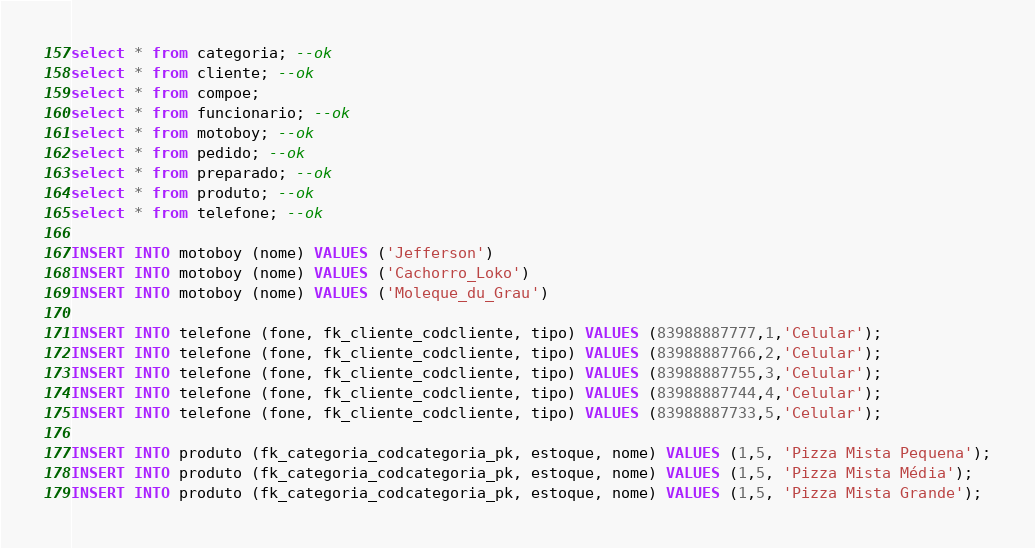Convert code to text. <code><loc_0><loc_0><loc_500><loc_500><_SQL_>select * from categoria; --ok
select * from cliente; --ok
select * from compoe; 
select * from funcionario; --ok
select * from motoboy; --ok
select * from pedido; --ok
select * from preparado; --ok
select * from produto; --ok
select * from telefone; --ok

INSERT INTO motoboy (nome) VALUES ('Jefferson')
INSERT INTO motoboy (nome) VALUES ('Cachorro_Loko')
INSERT INTO motoboy (nome) VALUES ('Moleque_du_Grau')

INSERT INTO telefone (fone, fk_cliente_codcliente, tipo) VALUES (83988887777,1,'Celular');
INSERT INTO telefone (fone, fk_cliente_codcliente, tipo) VALUES (83988887766,2,'Celular');
INSERT INTO telefone (fone, fk_cliente_codcliente, tipo) VALUES (83988887755,3,'Celular');
INSERT INTO telefone (fone, fk_cliente_codcliente, tipo) VALUES (83988887744,4,'Celular');
INSERT INTO telefone (fone, fk_cliente_codcliente, tipo) VALUES (83988887733,5,'Celular');

INSERT INTO produto (fk_categoria_codcategoria_pk, estoque, nome) VALUES (1,5, 'Pizza Mista Pequena');
INSERT INTO produto (fk_categoria_codcategoria_pk, estoque, nome) VALUES (1,5, 'Pizza Mista Média');
INSERT INTO produto (fk_categoria_codcategoria_pk, estoque, nome) VALUES (1,5, 'Pizza Mista Grande');</code> 